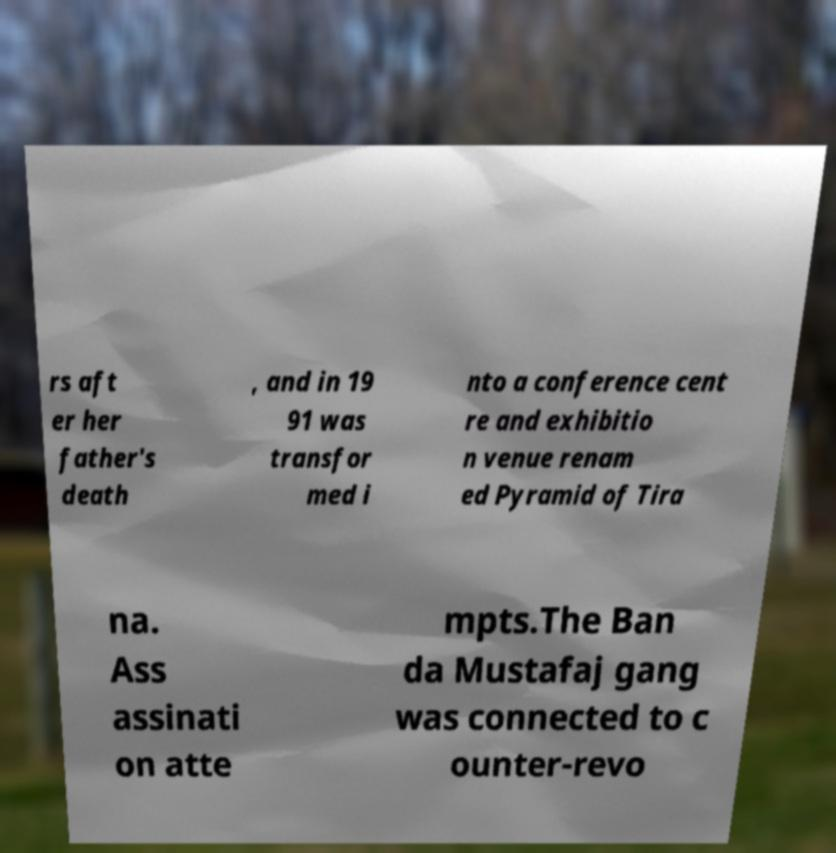Could you assist in decoding the text presented in this image and type it out clearly? rs aft er her father's death , and in 19 91 was transfor med i nto a conference cent re and exhibitio n venue renam ed Pyramid of Tira na. Ass assinati on atte mpts.The Ban da Mustafaj gang was connected to c ounter-revo 